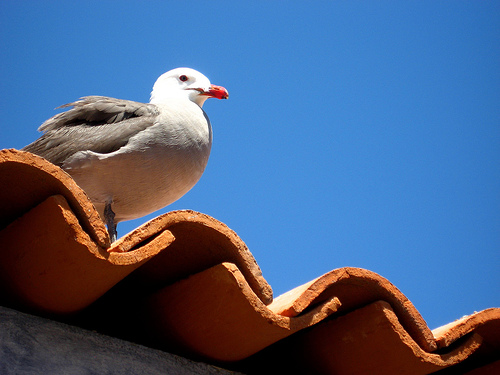<image>
Is the bird next to the tiles? No. The bird is not positioned next to the tiles. They are located in different areas of the scene. Is there a seagull next to the roof? No. The seagull is not positioned next to the roof. They are located in different areas of the scene. Is there a bird above the wall? Yes. The bird is positioned above the wall in the vertical space, higher up in the scene. 